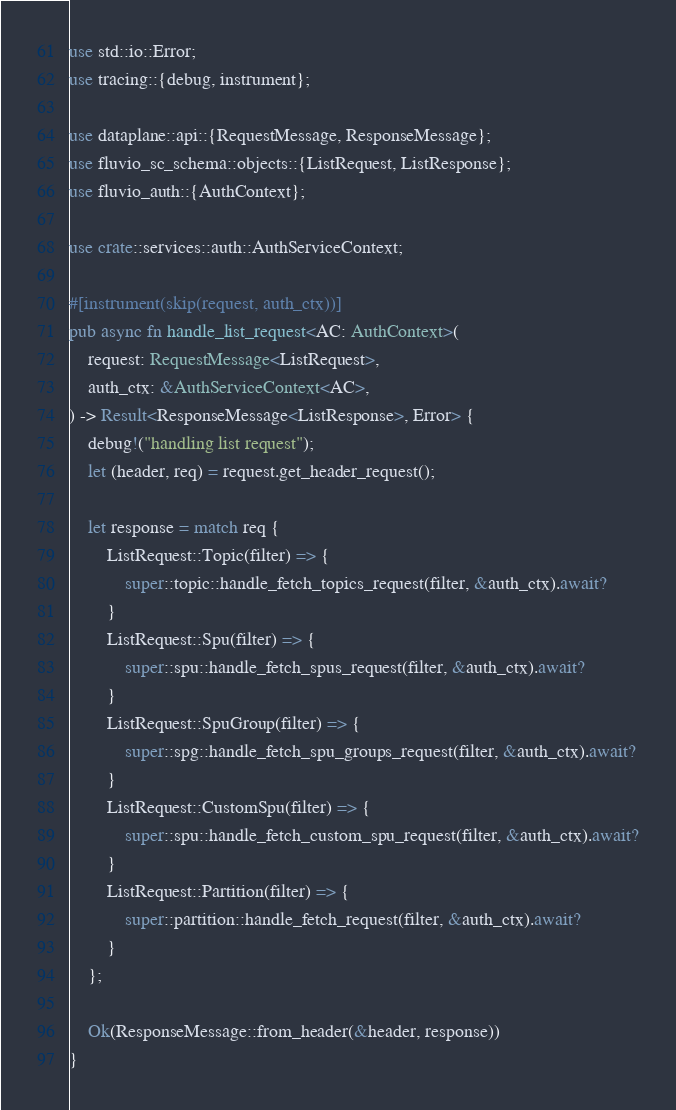Convert code to text. <code><loc_0><loc_0><loc_500><loc_500><_Rust_>use std::io::Error;
use tracing::{debug, instrument};

use dataplane::api::{RequestMessage, ResponseMessage};
use fluvio_sc_schema::objects::{ListRequest, ListResponse};
use fluvio_auth::{AuthContext};

use crate::services::auth::AuthServiceContext;

#[instrument(skip(request, auth_ctx))]
pub async fn handle_list_request<AC: AuthContext>(
    request: RequestMessage<ListRequest>,
    auth_ctx: &AuthServiceContext<AC>,
) -> Result<ResponseMessage<ListResponse>, Error> {
    debug!("handling list request");
    let (header, req) = request.get_header_request();

    let response = match req {
        ListRequest::Topic(filter) => {
            super::topic::handle_fetch_topics_request(filter, &auth_ctx).await?
        }
        ListRequest::Spu(filter) => {
            super::spu::handle_fetch_spus_request(filter, &auth_ctx).await?
        }
        ListRequest::SpuGroup(filter) => {
            super::spg::handle_fetch_spu_groups_request(filter, &auth_ctx).await?
        }
        ListRequest::CustomSpu(filter) => {
            super::spu::handle_fetch_custom_spu_request(filter, &auth_ctx).await?
        }
        ListRequest::Partition(filter) => {
            super::partition::handle_fetch_request(filter, &auth_ctx).await?
        }
    };

    Ok(ResponseMessage::from_header(&header, response))
}
</code> 